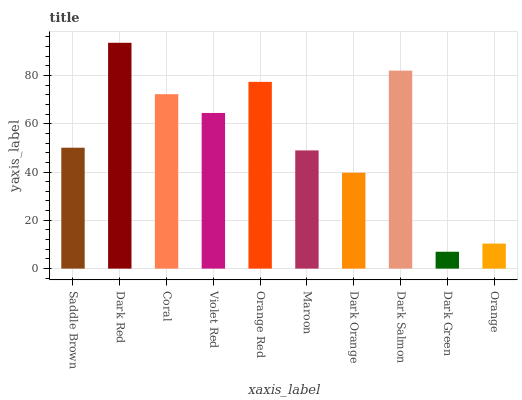Is Dark Green the minimum?
Answer yes or no. Yes. Is Dark Red the maximum?
Answer yes or no. Yes. Is Coral the minimum?
Answer yes or no. No. Is Coral the maximum?
Answer yes or no. No. Is Dark Red greater than Coral?
Answer yes or no. Yes. Is Coral less than Dark Red?
Answer yes or no. Yes. Is Coral greater than Dark Red?
Answer yes or no. No. Is Dark Red less than Coral?
Answer yes or no. No. Is Violet Red the high median?
Answer yes or no. Yes. Is Saddle Brown the low median?
Answer yes or no. Yes. Is Dark Orange the high median?
Answer yes or no. No. Is Dark Salmon the low median?
Answer yes or no. No. 